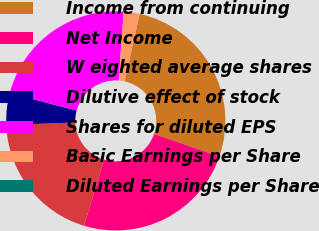Convert chart. <chart><loc_0><loc_0><loc_500><loc_500><pie_chart><fcel>Income from continuing<fcel>Net Income<fcel>W eighted average shares<fcel>Dilutive effect of stock<fcel>Shares for diluted EPS<fcel>Basic Earnings per Share<fcel>Diluted Earnings per Share<nl><fcel>26.76%<fcel>24.41%<fcel>19.71%<fcel>4.7%<fcel>22.06%<fcel>2.35%<fcel>0.0%<nl></chart> 